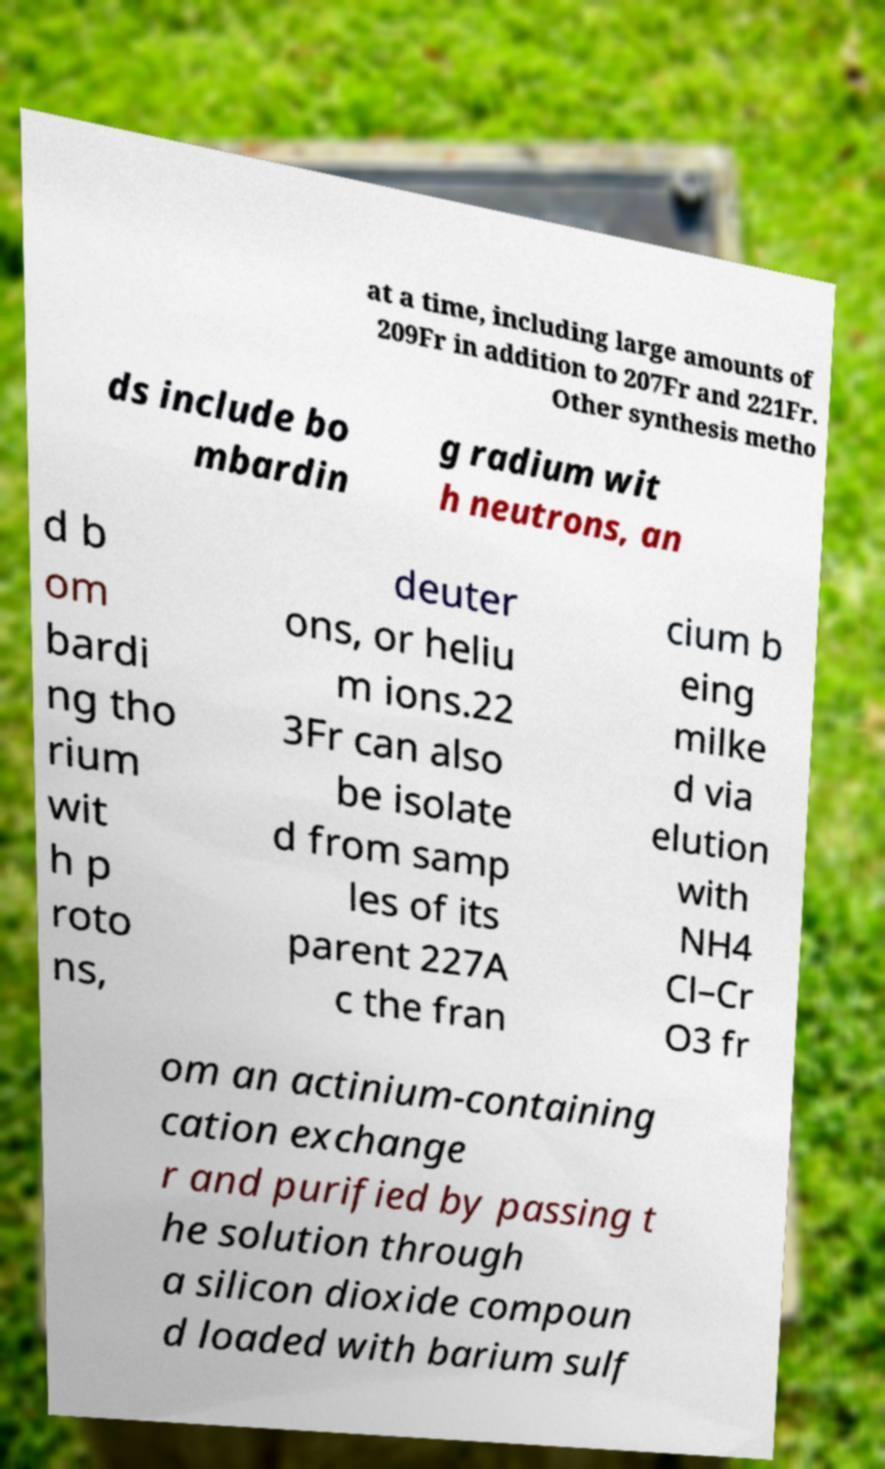Could you assist in decoding the text presented in this image and type it out clearly? at a time, including large amounts of 209Fr in addition to 207Fr and 221Fr. Other synthesis metho ds include bo mbardin g radium wit h neutrons, an d b om bardi ng tho rium wit h p roto ns, deuter ons, or heliu m ions.22 3Fr can also be isolate d from samp les of its parent 227A c the fran cium b eing milke d via elution with NH4 Cl–Cr O3 fr om an actinium-containing cation exchange r and purified by passing t he solution through a silicon dioxide compoun d loaded with barium sulf 